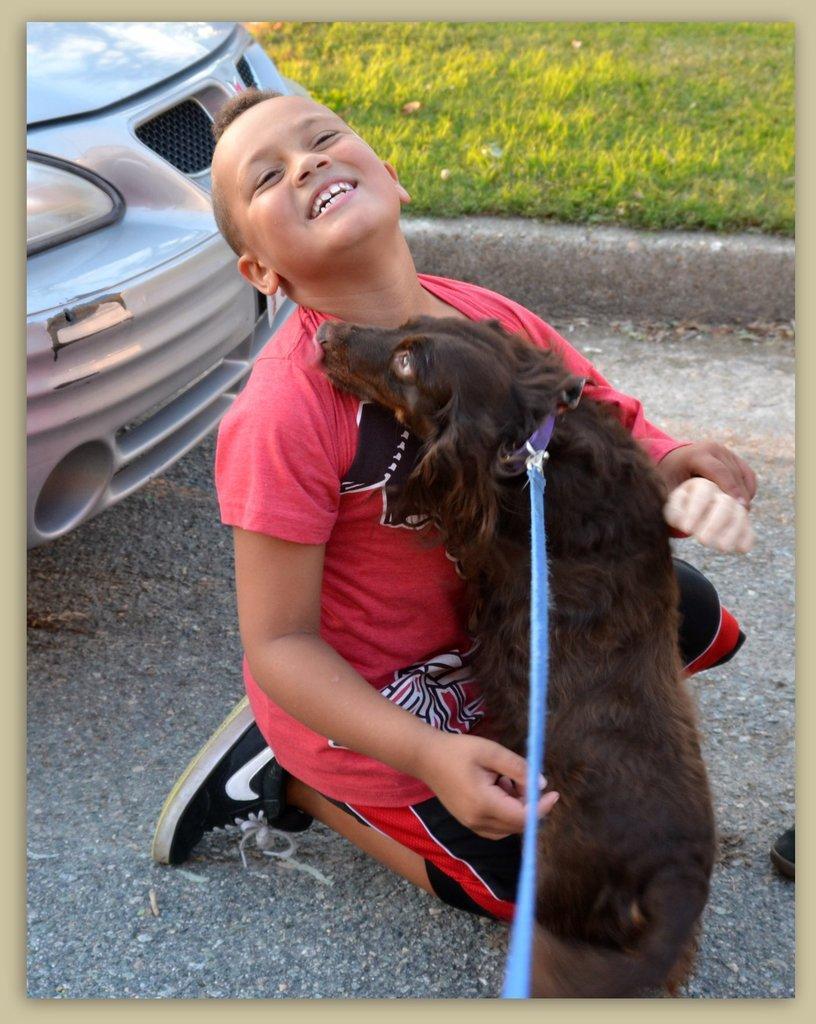Please provide a concise description of this image. in this image i can see a boy sitting on his knees. a dog is close to him. left to them is a car. behind them there is a grass and the boy is smiling. 